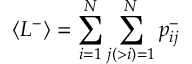<formula> <loc_0><loc_0><loc_500><loc_500>\langle L ^ { - } \rangle = \sum _ { i = 1 } ^ { N } \sum _ { j ( > i ) = 1 } ^ { N } p _ { i j } ^ { - }</formula> 